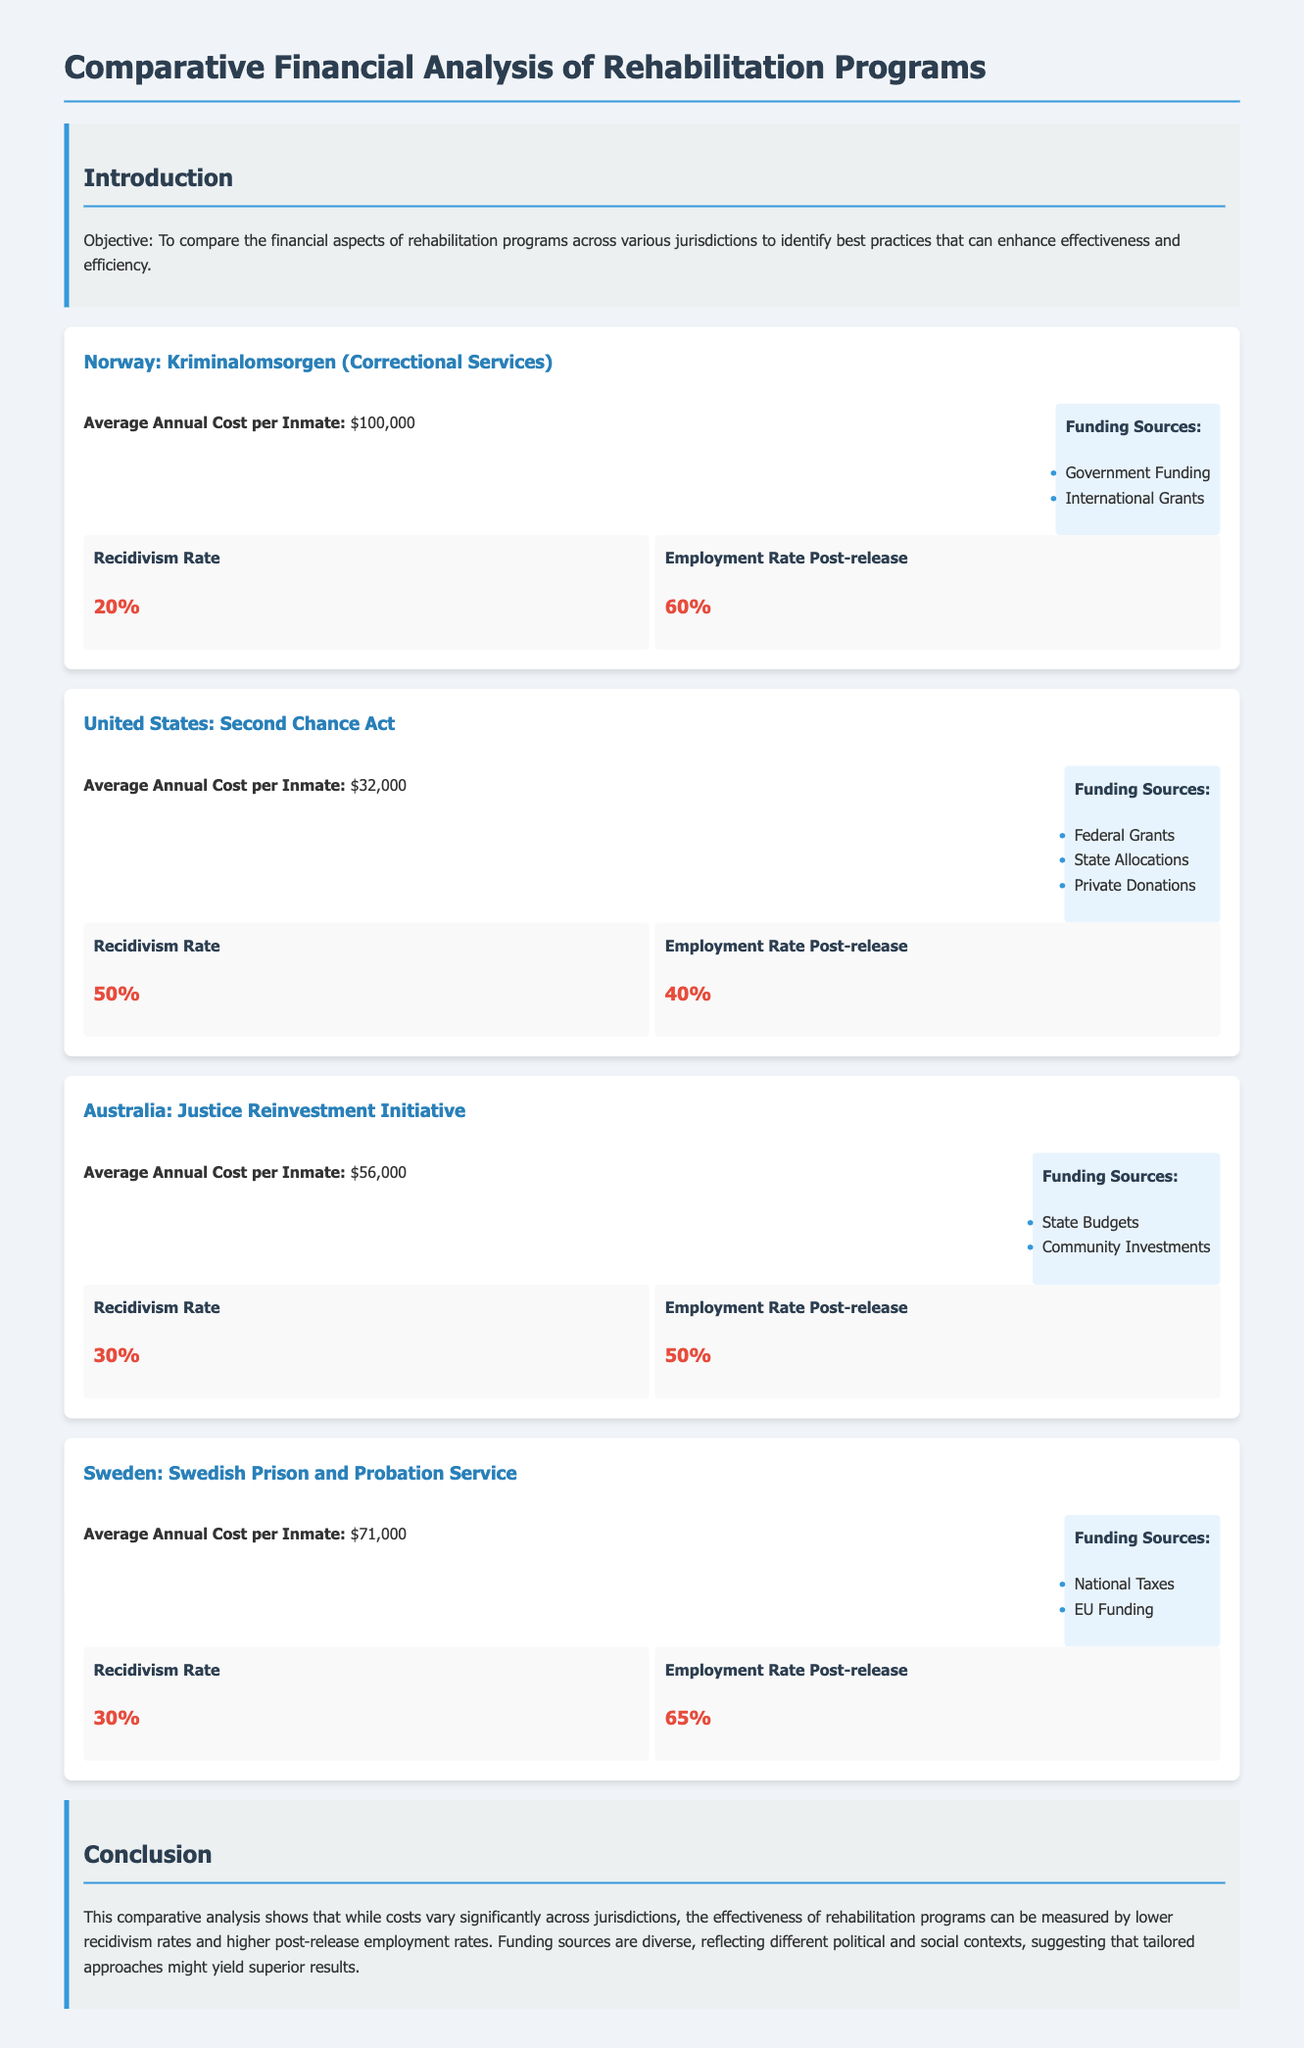What is the average annual cost per inmate in Norway? The average annual cost per inmate in Norway is clearly stated in the document as $100,000.
Answer: $100,000 What is the recidivism rate for the United States? The document specifies that the recidivism rate for the United States is 50%.
Answer: 50% Which funding sources are listed for Australia's rehabilitation program? The funding sources for Australia's program are detailed in the document as State Budgets and Community Investments.
Answer: State Budgets, Community Investments What is the employment rate post-release in Sweden? The document indicates that the employment rate post-release in Sweden is 65%.
Answer: 65% Which jurisdiction has the highest average annual cost per inmate? By comparing the costs listed, it's evident that Norway has the highest average annual cost per inmate at $100,000.
Answer: Norway What funding source is mentioned for the United States rehabilitation program? The document lists Federal Grants as one of the funding sources for the United States rehabilitation program.
Answer: Federal Grants What is the average annual cost per inmate in Australia? The average annual cost per inmate in Australia is presented in the document as $56,000.
Answer: $56,000 Which rehabilitation program has the lowest recidivism rate among the jurisdictions compared? Analyzing the recidivism rates provided, it is clear that Norway has the lowest recidivism rate at 20%.
Answer: Norway What conclusion does the document make regarding rehabilitation program effectiveness? The conclusion drawn in the document suggests that lower recidivism rates and higher employment rates indicate more effective rehabilitation programs.
Answer: Lower recidivism rates and higher employment rates indicate more effective rehabilitation programs 